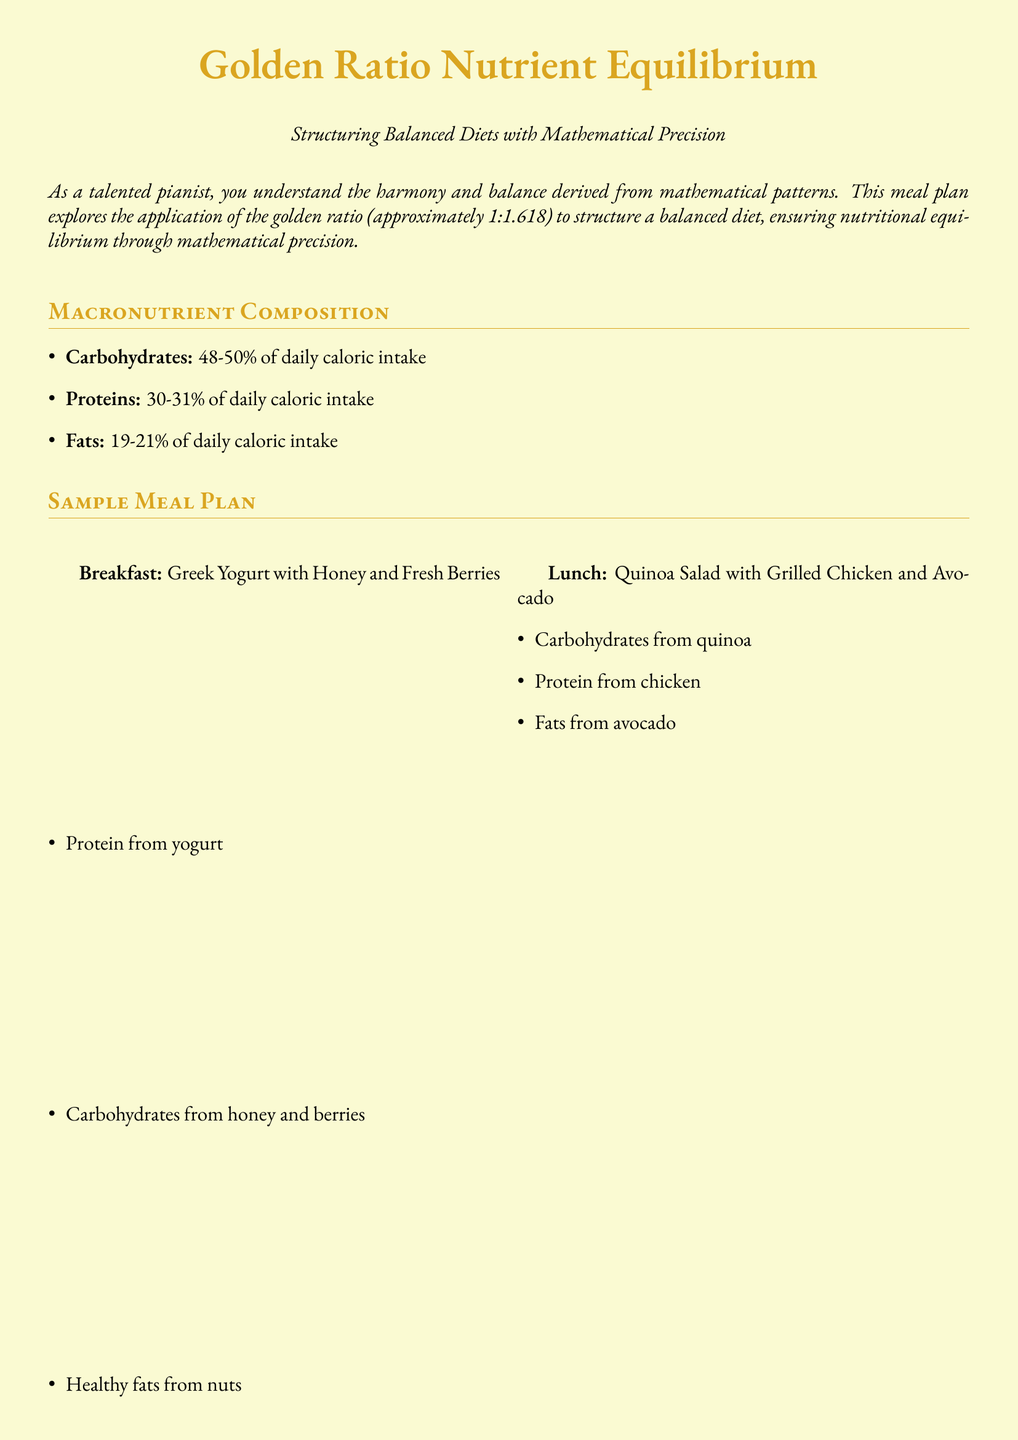What is the daily caloric intake percentage for carbohydrates? The document states that carbohydrates represent 48-50% of daily caloric intake.
Answer: 48-50% What type of meal is suggested for breakfast? The breakfast meal plan includes Greek Yogurt with Honey and Fresh Berries.
Answer: Greek Yogurt with Honey and Fresh Berries What macronutrient has the highest percentage in the meal plan? Proteins are allocated 30-31% of the daily caloric intake, which is the highest after carbohydrates.
Answer: Proteins What nutritional component do mixed nuts provide? Mixed Nuts and Dark Chocolate are highlighted for their healthy fats.
Answer: Healthy fats How many meals are included in the sample meal plan? The meal plan outlines four main meals: Breakfast, Lunch, Snacks, and Dinner.
Answer: Four What is one nutritional tip provided for pianists? The document offers tips including staying hydrated to maintain focus and energy.
Answer: Stay hydrated What serving is suggested for dinner? The dinner meal plan includes Baked Salmon with Sweet Potato and Steamed Broccoli.
Answer: Baked Salmon with Sweet Potato and Steamed Broccoli What is the primary benefit highlighted for incorporating antioxidants? The document emphasizes support for overall brain health with antioxidant-rich foods.
Answer: Brain health 